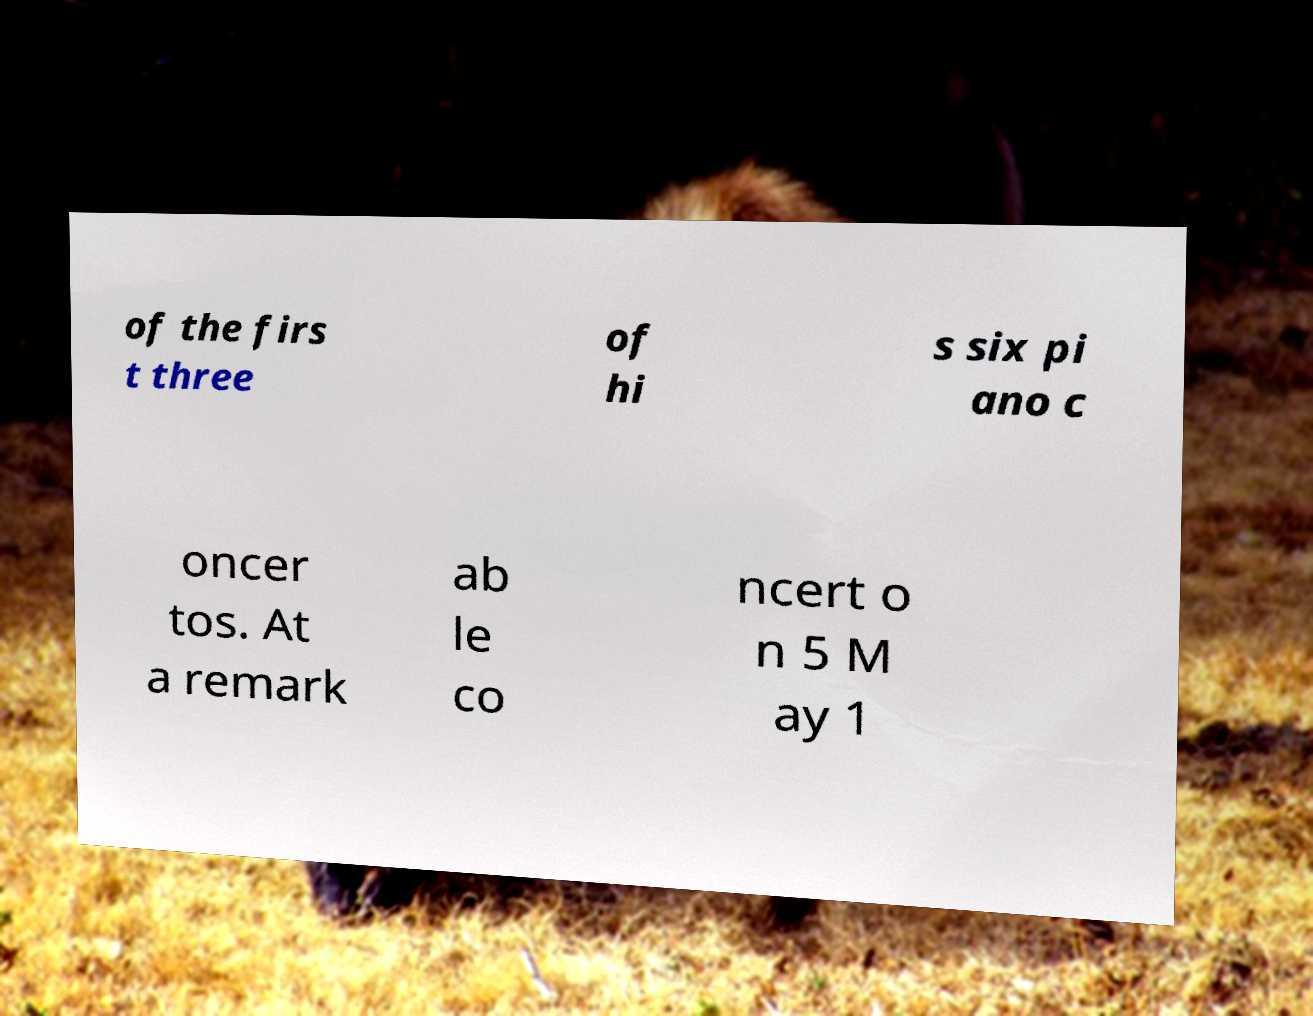For documentation purposes, I need the text within this image transcribed. Could you provide that? of the firs t three of hi s six pi ano c oncer tos. At a remark ab le co ncert o n 5 M ay 1 